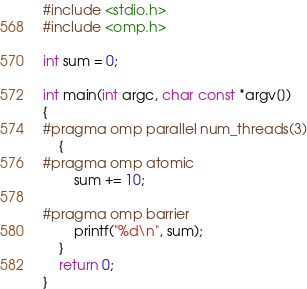Convert code to text. <code><loc_0><loc_0><loc_500><loc_500><_C_>#include <stdio.h>
#include <omp.h>

int sum = 0;

int main(int argc, char const *argv[])
{
#pragma omp parallel num_threads(3)
    {
#pragma omp atomic
        sum += 10;

#pragma omp barrier
        printf("%d\n", sum);
    }
    return 0;
}
</code> 